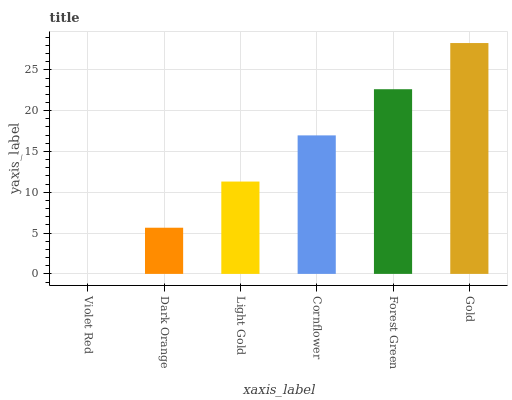Is Dark Orange the minimum?
Answer yes or no. No. Is Dark Orange the maximum?
Answer yes or no. No. Is Dark Orange greater than Violet Red?
Answer yes or no. Yes. Is Violet Red less than Dark Orange?
Answer yes or no. Yes. Is Violet Red greater than Dark Orange?
Answer yes or no. No. Is Dark Orange less than Violet Red?
Answer yes or no. No. Is Cornflower the high median?
Answer yes or no. Yes. Is Light Gold the low median?
Answer yes or no. Yes. Is Dark Orange the high median?
Answer yes or no. No. Is Gold the low median?
Answer yes or no. No. 